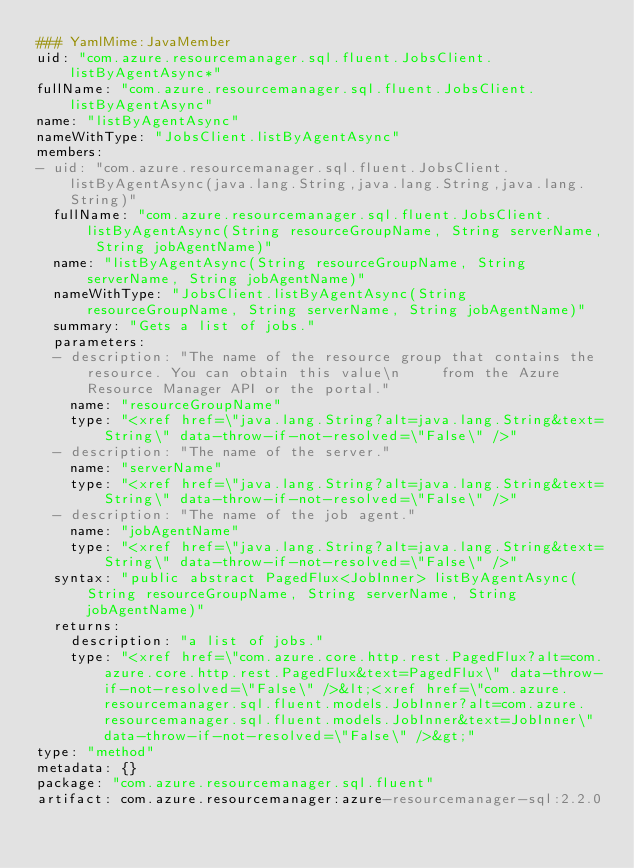<code> <loc_0><loc_0><loc_500><loc_500><_YAML_>### YamlMime:JavaMember
uid: "com.azure.resourcemanager.sql.fluent.JobsClient.listByAgentAsync*"
fullName: "com.azure.resourcemanager.sql.fluent.JobsClient.listByAgentAsync"
name: "listByAgentAsync"
nameWithType: "JobsClient.listByAgentAsync"
members:
- uid: "com.azure.resourcemanager.sql.fluent.JobsClient.listByAgentAsync(java.lang.String,java.lang.String,java.lang.String)"
  fullName: "com.azure.resourcemanager.sql.fluent.JobsClient.listByAgentAsync(String resourceGroupName, String serverName, String jobAgentName)"
  name: "listByAgentAsync(String resourceGroupName, String serverName, String jobAgentName)"
  nameWithType: "JobsClient.listByAgentAsync(String resourceGroupName, String serverName, String jobAgentName)"
  summary: "Gets a list of jobs."
  parameters:
  - description: "The name of the resource group that contains the resource. You can obtain this value\n     from the Azure Resource Manager API or the portal."
    name: "resourceGroupName"
    type: "<xref href=\"java.lang.String?alt=java.lang.String&text=String\" data-throw-if-not-resolved=\"False\" />"
  - description: "The name of the server."
    name: "serverName"
    type: "<xref href=\"java.lang.String?alt=java.lang.String&text=String\" data-throw-if-not-resolved=\"False\" />"
  - description: "The name of the job agent."
    name: "jobAgentName"
    type: "<xref href=\"java.lang.String?alt=java.lang.String&text=String\" data-throw-if-not-resolved=\"False\" />"
  syntax: "public abstract PagedFlux<JobInner> listByAgentAsync(String resourceGroupName, String serverName, String jobAgentName)"
  returns:
    description: "a list of jobs."
    type: "<xref href=\"com.azure.core.http.rest.PagedFlux?alt=com.azure.core.http.rest.PagedFlux&text=PagedFlux\" data-throw-if-not-resolved=\"False\" />&lt;<xref href=\"com.azure.resourcemanager.sql.fluent.models.JobInner?alt=com.azure.resourcemanager.sql.fluent.models.JobInner&text=JobInner\" data-throw-if-not-resolved=\"False\" />&gt;"
type: "method"
metadata: {}
package: "com.azure.resourcemanager.sql.fluent"
artifact: com.azure.resourcemanager:azure-resourcemanager-sql:2.2.0
</code> 